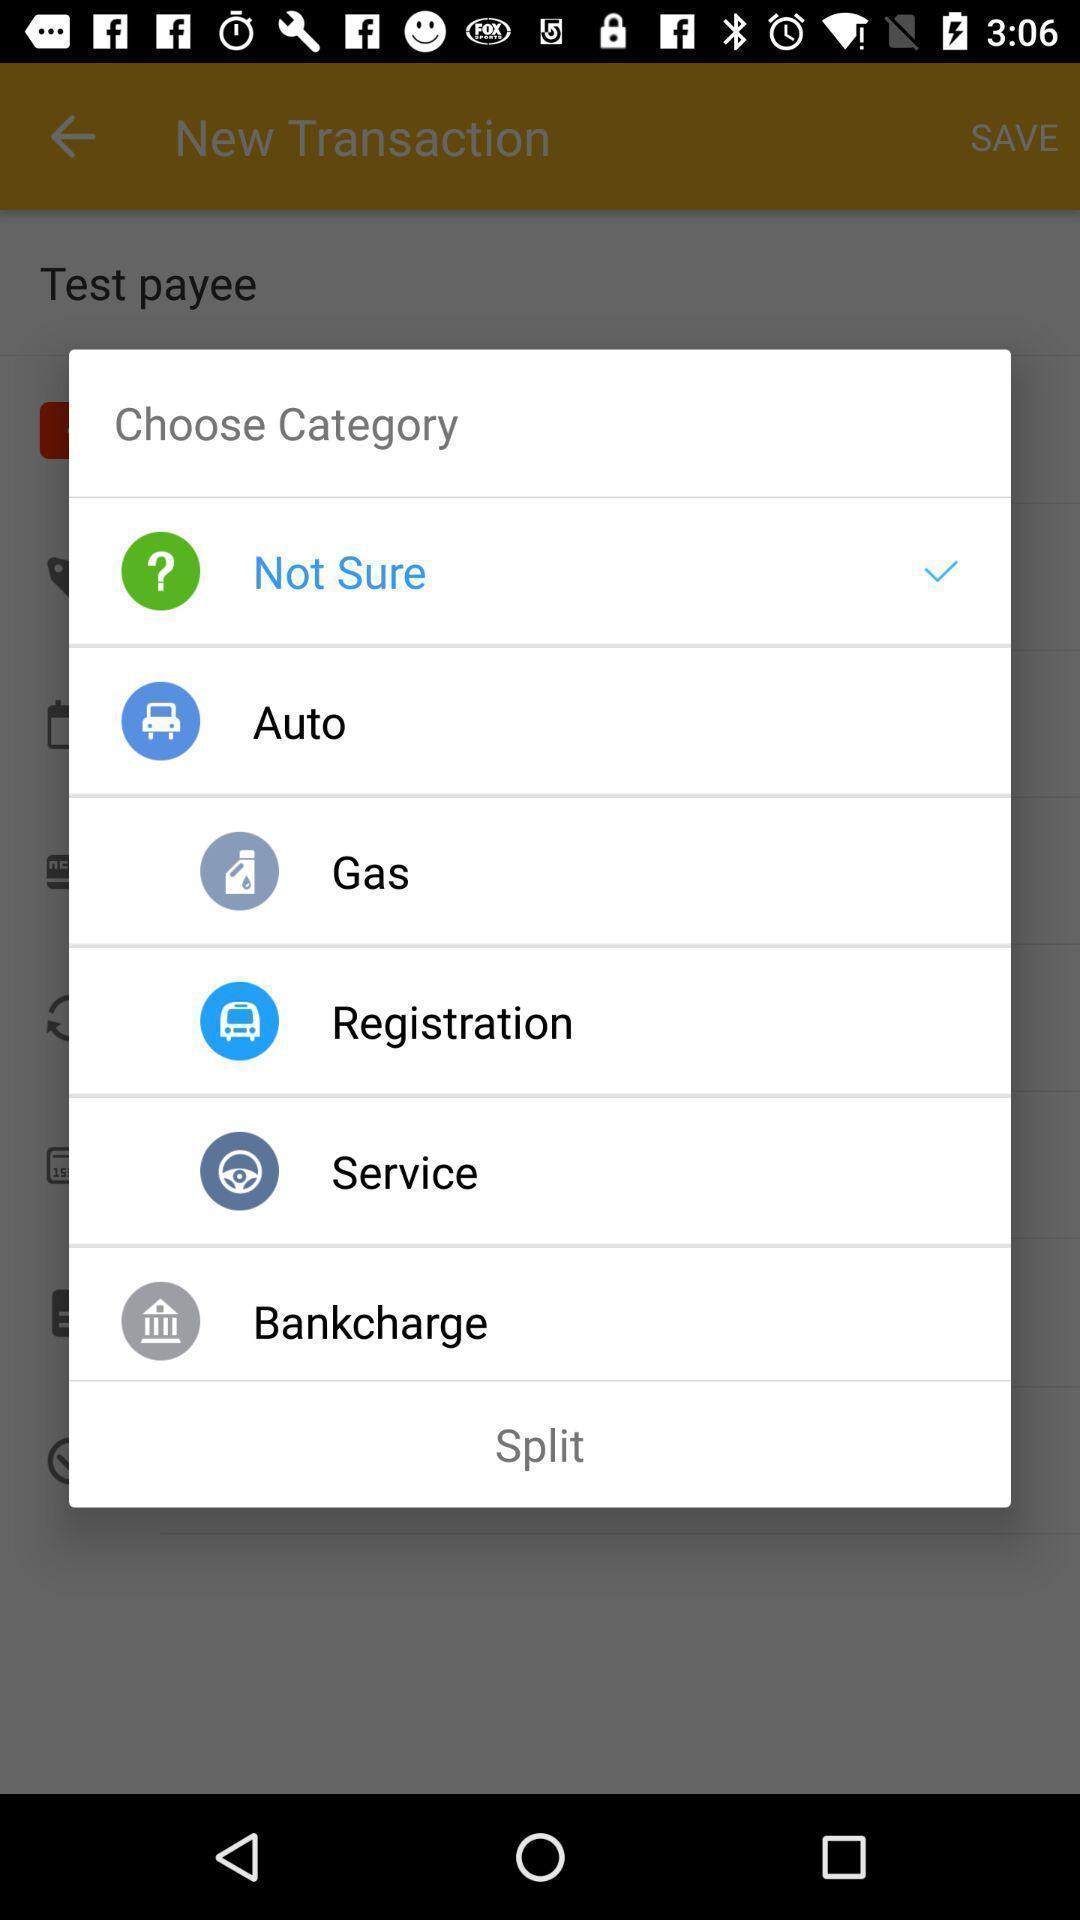Give me a narrative description of this picture. Pop-up showing parameters of a category. 